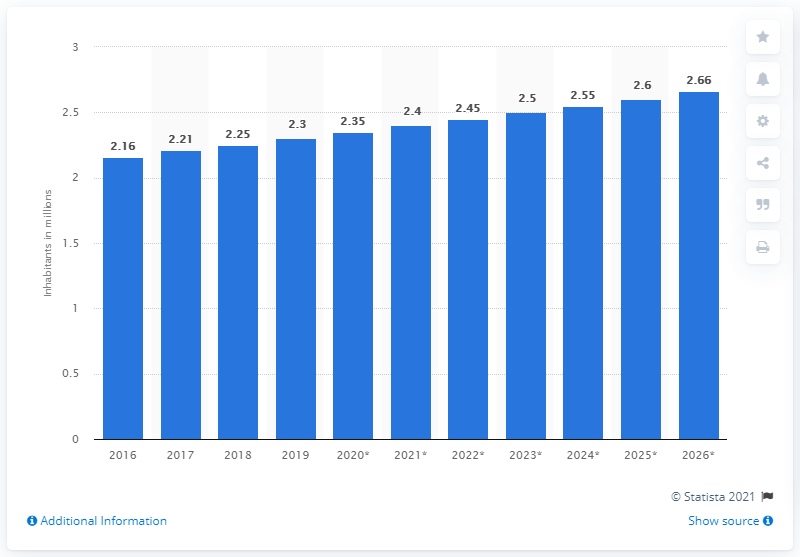Indicate a few pertinent items in this graphic. In 2019, the population of Botswana was approximately 2.3 million people. 